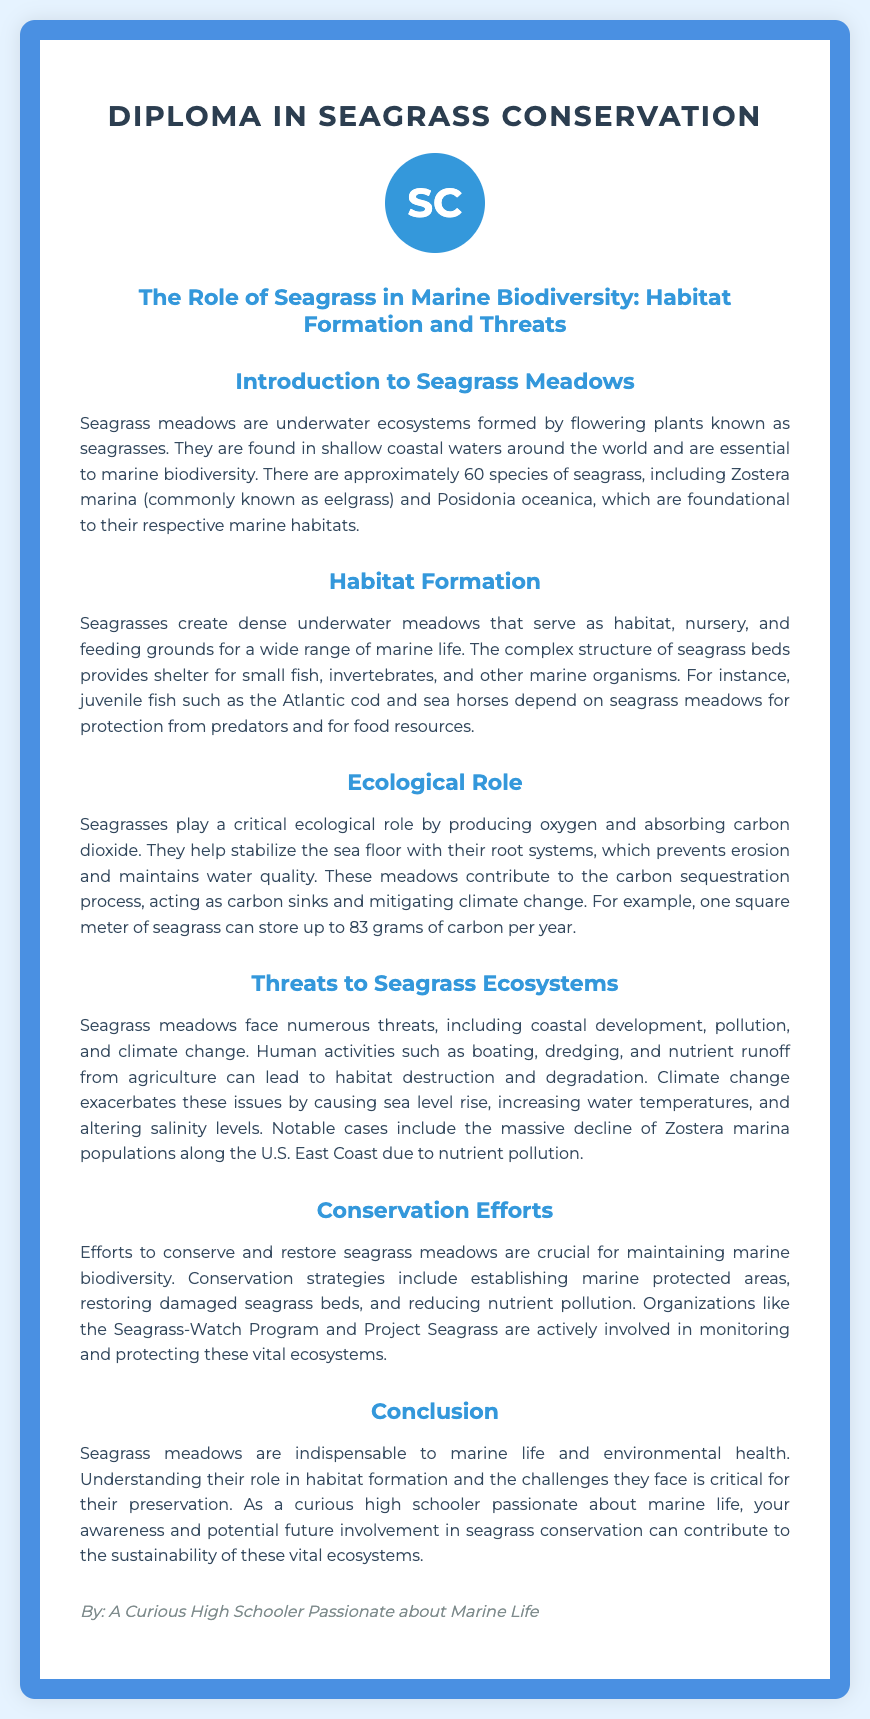What is the title of the diploma? The title of the diploma is stated prominently at the top of the document.
Answer: Diploma in Seagrass Conservation How many species of seagrass are there approximately? The document indicates that there are around 60 species of seagrass.
Answer: 60 Which species is commonly known as eelgrass? The document mentions Zostera marina as the common name for eelgrass.
Answer: Zostera marina What role do seagrasses play in carbon sequestration? The document notes that seagrasses contribute to the carbon sequestration process, acting as carbon sinks.
Answer: Carbon sinks What is one major threat to seagrass ecosystems mentioned in the document? The document lists several threats, including coastal development as a major one.
Answer: Coastal development What conservation strategy involves protecting certain areas of the ocean? The document refers to establishing marine protected areas as a strategy.
Answer: Marine protected areas Name one organization actively involved in seagrass conservation. The document mentions organizations such as the Seagrass-Watch Program.
Answer: Seagrass-Watch Program What is the estimated carbon storage per square meter of seagrass per year? The document provides a specific figure regarding carbon storage in seagrass meadows.
Answer: 83 grams What is the conclusion about seagrass meadows in the document? The conclusion summarizes the importance of seagrass meadows and the need for conservation efforts.
Answer: Indispensable to marine life and environmental health 